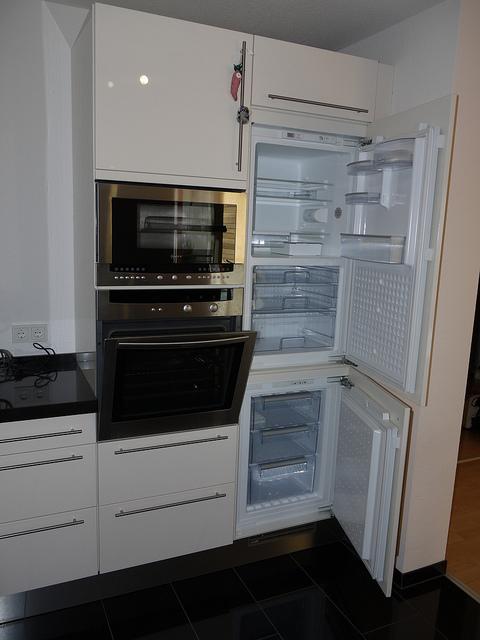What color is the microwave?
Give a very brief answer. Silver. How modern is the kitchen?
Be succinct. Very modern. How many appliances belong in the kitchen?
Answer briefly. 3. Is this room dirty or clean?
Quick response, please. Clean. What is in the oven?
Write a very short answer. Nothing. What is behind the closed doors?
Quick response, please. Nothing. Is there greenery in the kitchen?
Concise answer only. No. Is this a big kitchen?
Give a very brief answer. No. Is this the living room?
Keep it brief. No. Is this outside?
Short answer required. No. How many ovens are in this kitchen?
Concise answer only. 1. Is this refrigerator new?
Keep it brief. Yes. What is this room called?
Be succinct. Kitchen. Is the oven closed?
Short answer required. No. Is this a home kitchen?
Give a very brief answer. Yes. Is the fridge stocked?
Give a very brief answer. No. Is the microwave old?
Give a very brief answer. No. Is the cabinet new?
Keep it brief. Yes. Is this house well lived in?
Quick response, please. No. Is this refrigerator plugged in?
Concise answer only. No. What patterns are on the floor?
Concise answer only. Square. Is the oven open?
Answer briefly. Yes. What color are the cabinets?
Short answer required. White. Is this fridge closed?
Write a very short answer. No. How many microwaves are there?
Be succinct. 1. Are the appliances stainless steel?
Quick response, please. Yes. What are the cabinets made of?
Concise answer only. Wood. What room of the house is this?
Keep it brief. Kitchen. Is the microwave kitty cornered?
Keep it brief. No. What is the icebox color?
Concise answer only. White. What is on top of the refrigerator?
Short answer required. Cabinet. 